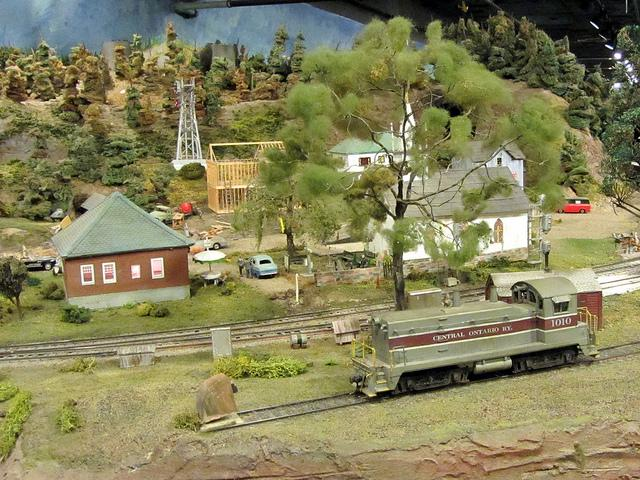What type of scene is this? miniature 